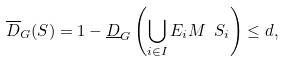<formula> <loc_0><loc_0><loc_500><loc_500>\overline { D } _ { G } ( S ) = 1 - \underline { D } _ { G } \left ( \bigcup _ { i \in I } E _ { i } M \ S _ { i } \right ) \leq d ,</formula> 